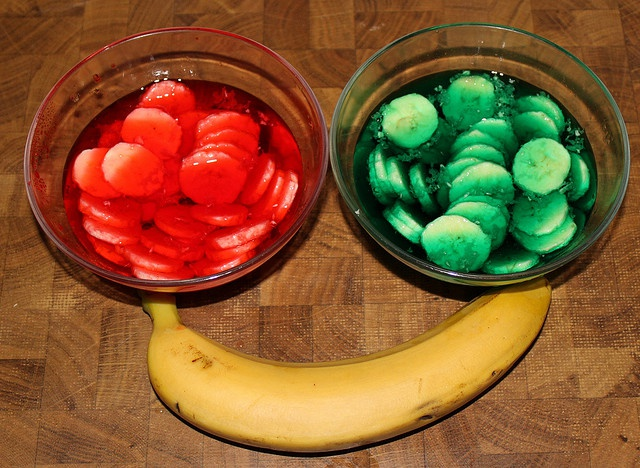Describe the objects in this image and their specific colors. I can see dining table in brown, maroon, black, and red tones, banana in maroon, orange, gold, and olive tones, banana in maroon, red, brown, and salmon tones, and banana in maroon, green, darkgreen, black, and lightgreen tones in this image. 